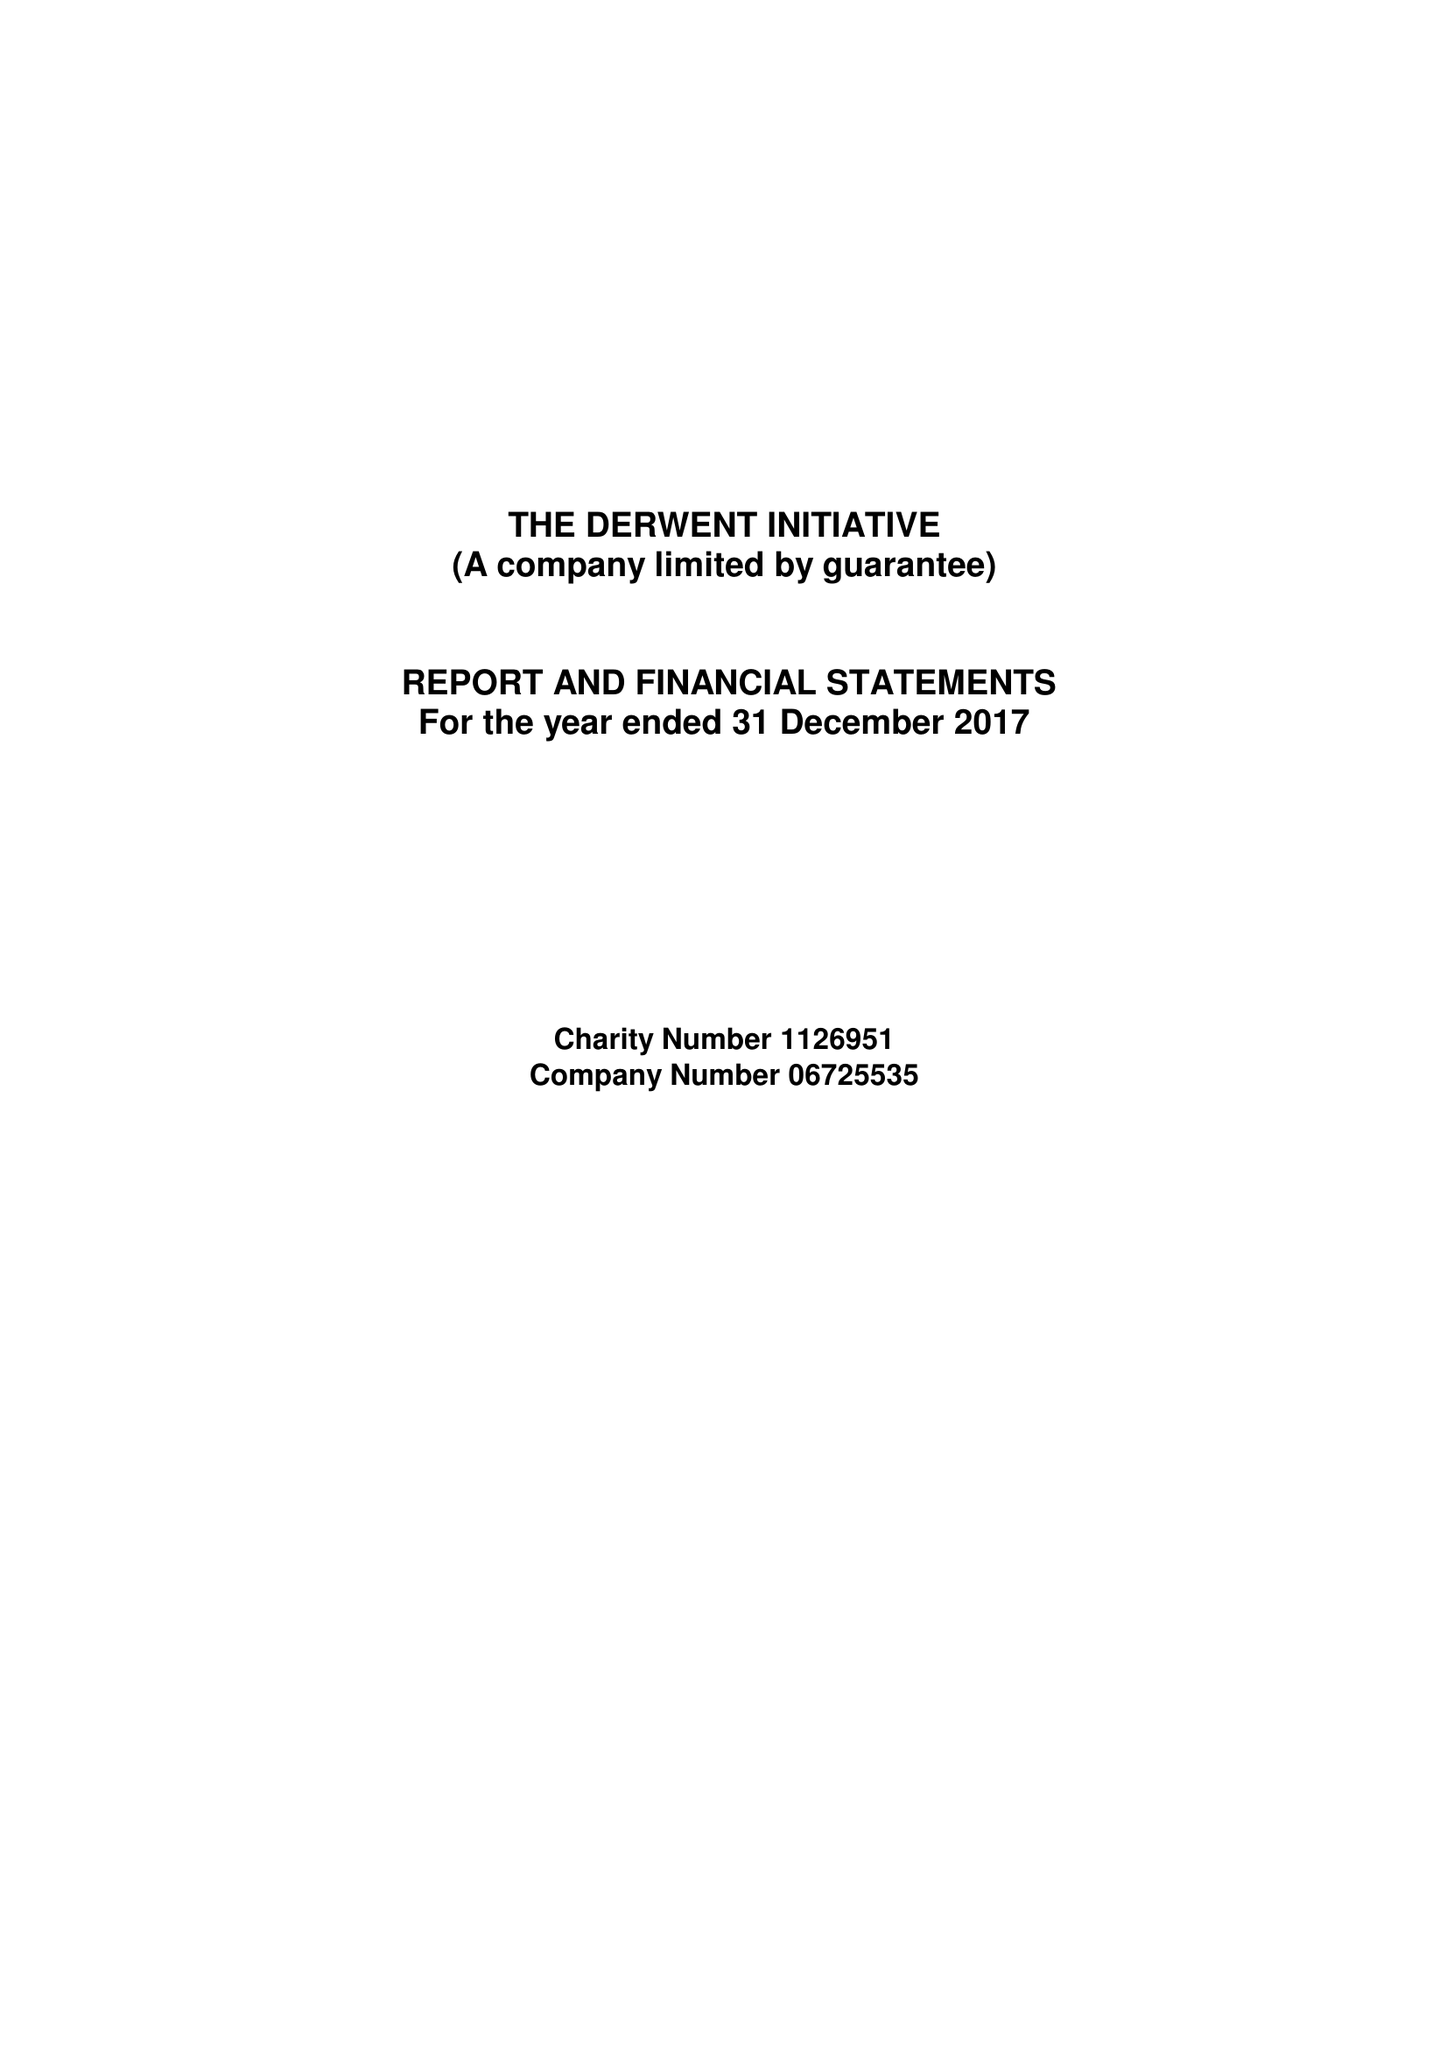What is the value for the charity_name?
Answer the question using a single word or phrase. The Derwent Initiative 